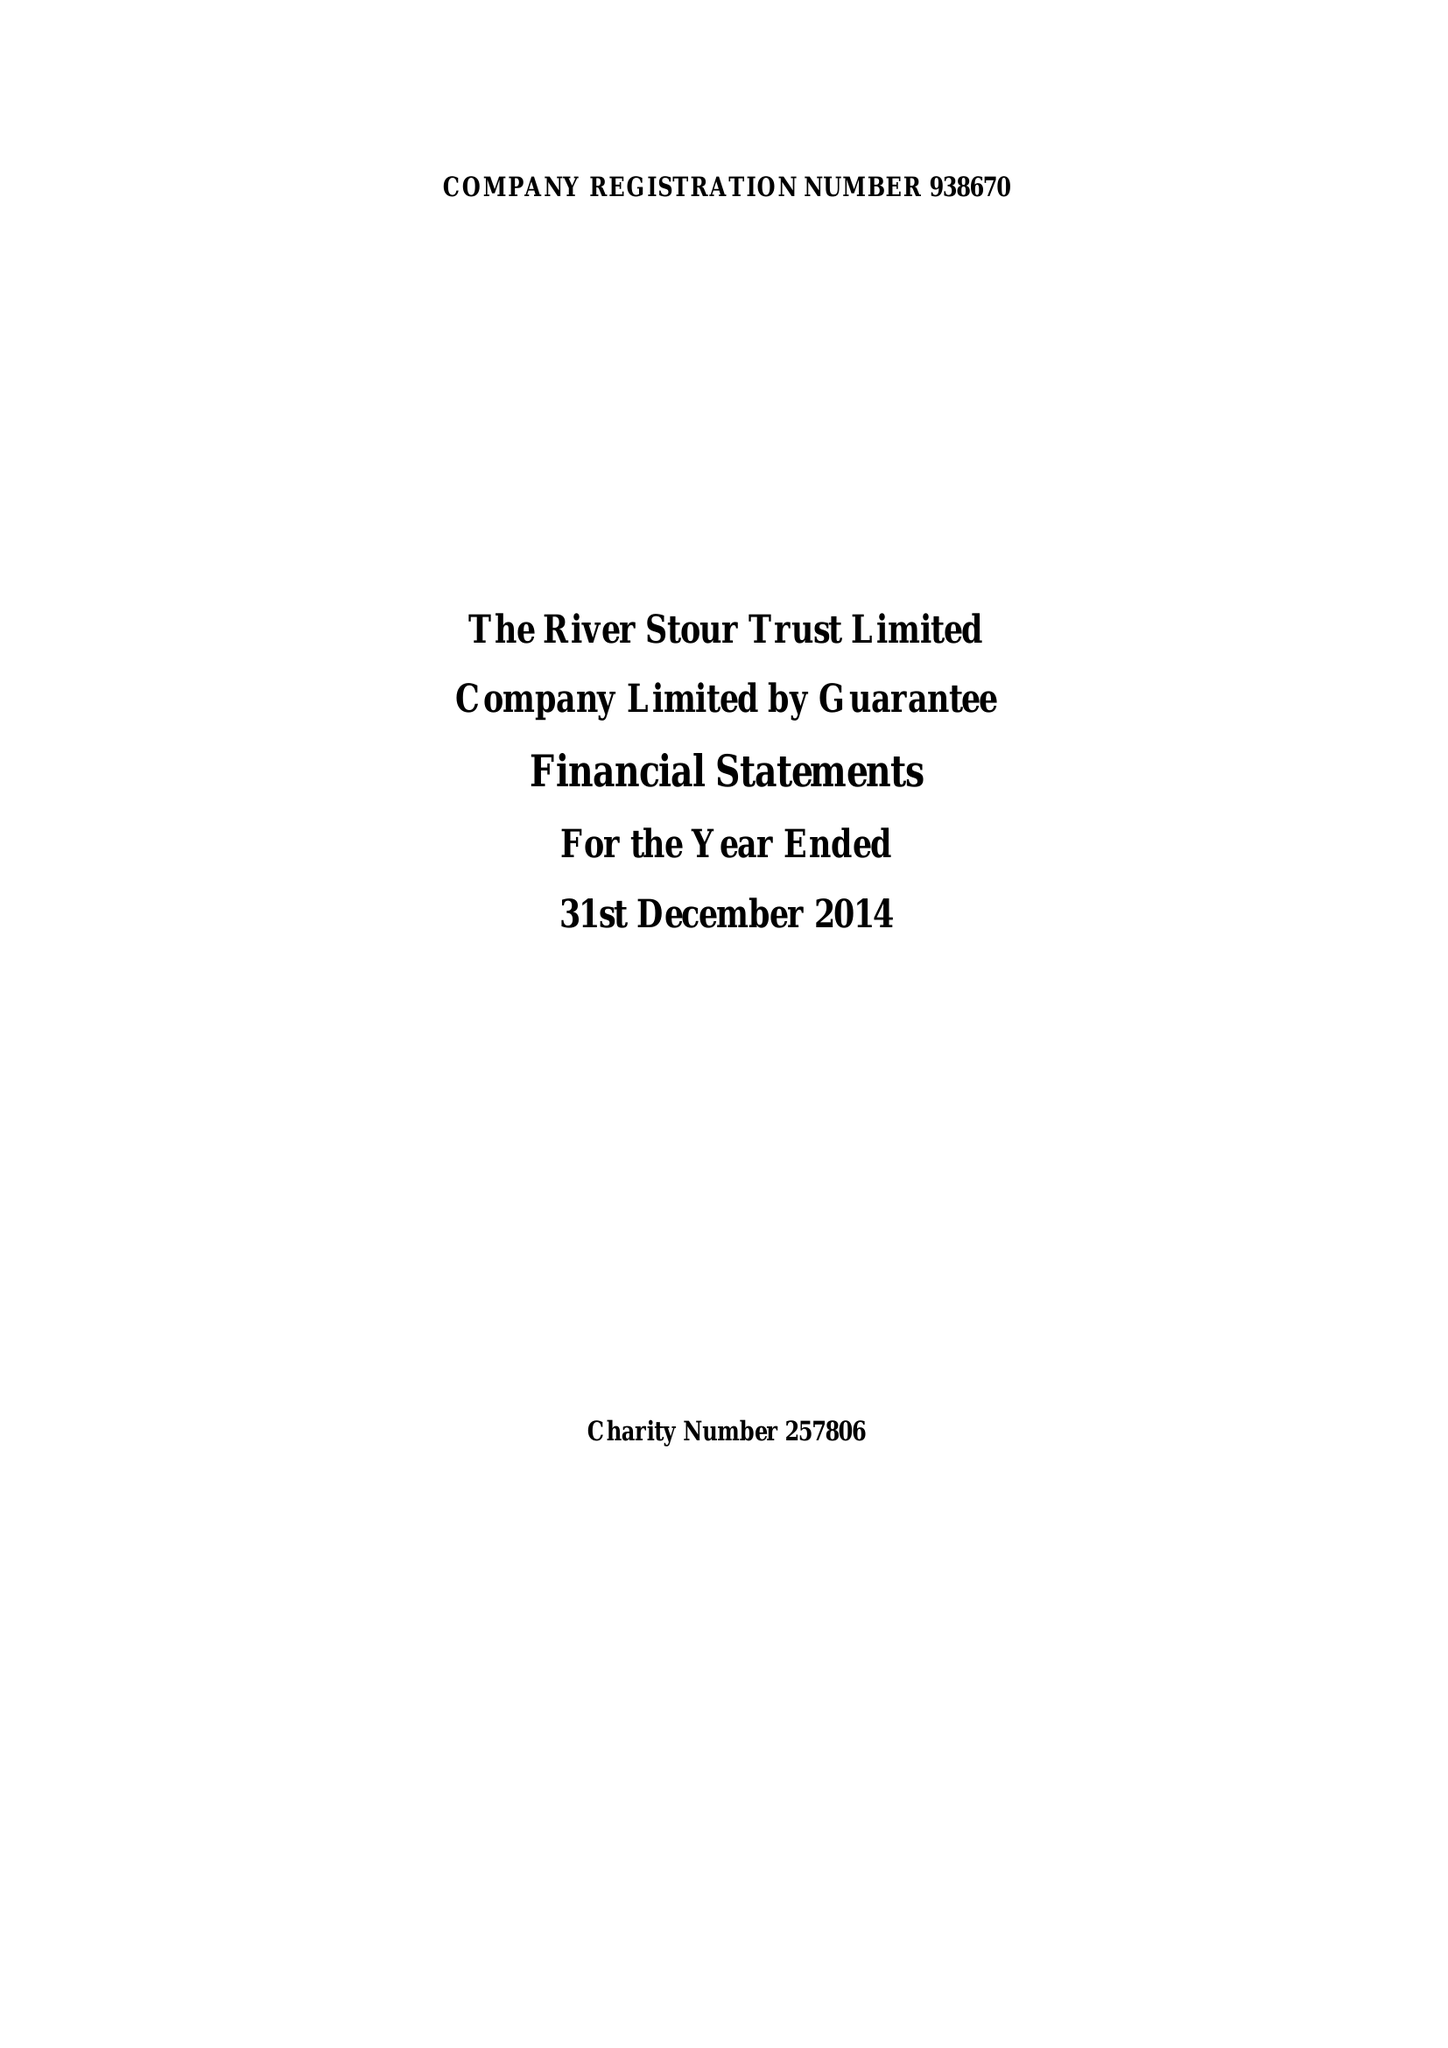What is the value for the address__street_line?
Answer the question using a single word or phrase. None 